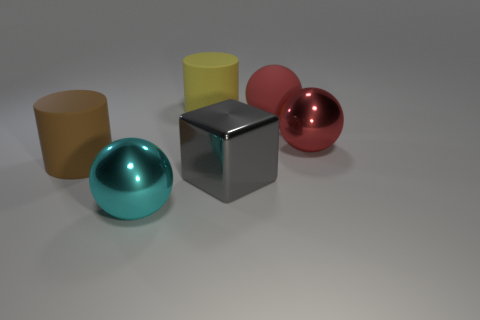There is a rubber sphere that is the same size as the shiny block; what is its color?
Provide a short and direct response. Red. What number of tiny things are either gray objects or cyan metal things?
Offer a terse response. 0. Is the number of brown cylinders on the right side of the gray metallic cube greater than the number of cyan objects left of the yellow cylinder?
Offer a very short reply. No. There is a metal sphere that is the same color as the large matte sphere; what size is it?
Keep it short and to the point. Large. What number of other objects are the same size as the gray shiny block?
Ensure brevity in your answer.  5. Does the sphere in front of the big gray shiny thing have the same material as the gray cube?
Ensure brevity in your answer.  Yes. How many other objects are there of the same color as the big matte ball?
Provide a succinct answer. 1. What number of other objects are there of the same shape as the gray object?
Provide a short and direct response. 0. There is a shiny object on the right side of the matte sphere; is its shape the same as the red thing behind the big red metallic thing?
Your response must be concise. Yes. Are there the same number of yellow cylinders that are to the right of the large gray shiny cube and large gray shiny blocks that are on the right side of the large yellow matte object?
Your response must be concise. No. 